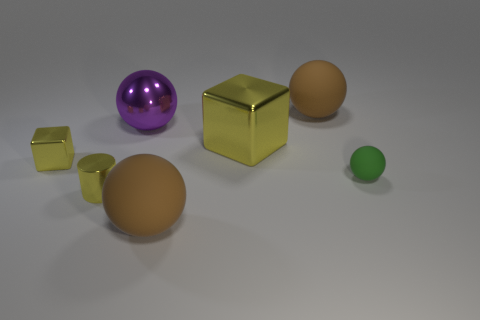Do the shiny cylinder and the metal block on the right side of the large purple sphere have the same color?
Your answer should be very brief. Yes. Are there any large yellow metallic things that have the same shape as the green object?
Give a very brief answer. No. What number of things are either small yellow blocks or blocks to the right of the cylinder?
Ensure brevity in your answer.  2. What number of other things are there of the same material as the green object
Provide a succinct answer. 2. What number of things are either large gray matte cylinders or yellow metal cubes?
Keep it short and to the point. 2. Are there more brown rubber balls in front of the purple metallic object than tiny rubber things that are behind the small rubber thing?
Your response must be concise. Yes. Is the color of the small thing to the right of the large purple thing the same as the big matte object that is to the right of the large yellow block?
Your answer should be compact. No. There is a purple metal sphere that is on the right side of the yellow block that is to the left of the large brown ball in front of the purple metallic thing; what is its size?
Make the answer very short. Large. What color is the other large metallic object that is the same shape as the green object?
Your answer should be compact. Purple. Is the number of small yellow metal cylinders that are behind the small yellow shiny cube greater than the number of green objects?
Offer a terse response. No. 